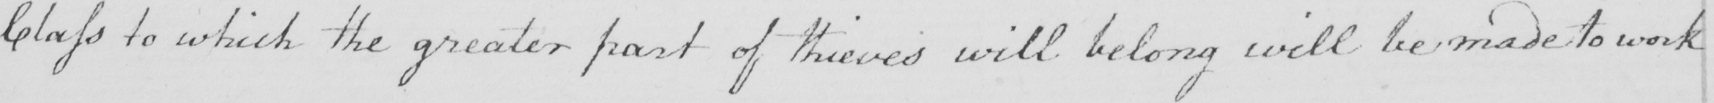Please provide the text content of this handwritten line. Class to which the greater part of thieves will belong will be made to work 